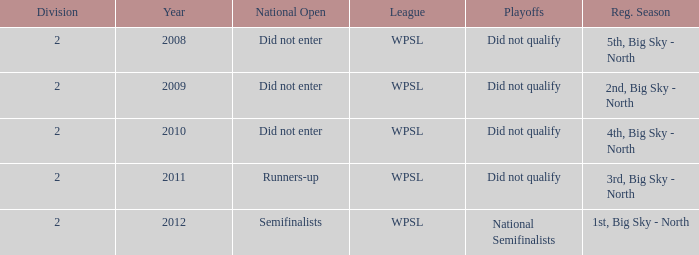What league was involved in 2008? WPSL. Can you parse all the data within this table? {'header': ['Division', 'Year', 'National Open', 'League', 'Playoffs', 'Reg. Season'], 'rows': [['2', '2008', 'Did not enter', 'WPSL', 'Did not qualify', '5th, Big Sky - North'], ['2', '2009', 'Did not enter', 'WPSL', 'Did not qualify', '2nd, Big Sky - North'], ['2', '2010', 'Did not enter', 'WPSL', 'Did not qualify', '4th, Big Sky - North'], ['2', '2011', 'Runners-up', 'WPSL', 'Did not qualify', '3rd, Big Sky - North'], ['2', '2012', 'Semifinalists', 'WPSL', 'National Semifinalists', '1st, Big Sky - North']]} 